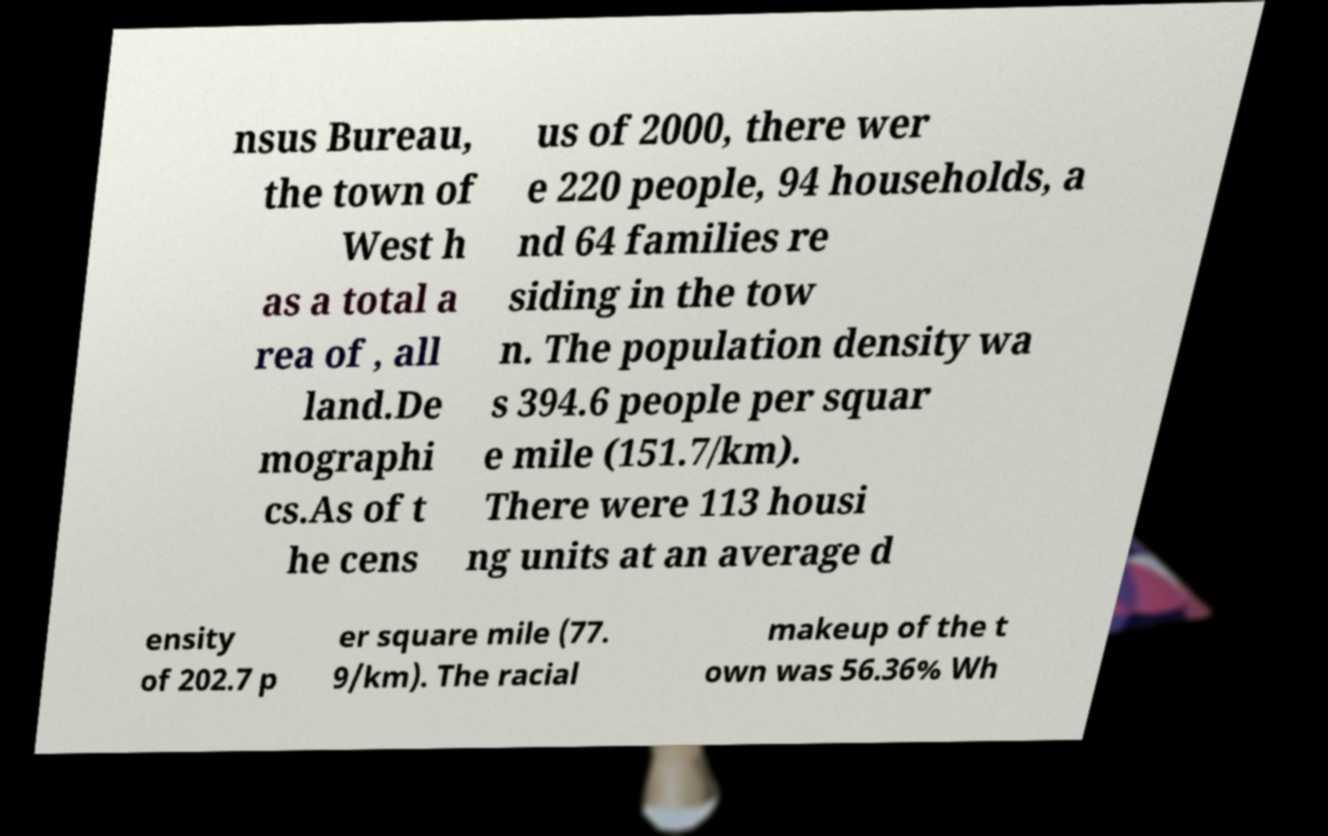For documentation purposes, I need the text within this image transcribed. Could you provide that? nsus Bureau, the town of West h as a total a rea of , all land.De mographi cs.As of t he cens us of 2000, there wer e 220 people, 94 households, a nd 64 families re siding in the tow n. The population density wa s 394.6 people per squar e mile (151.7/km). There were 113 housi ng units at an average d ensity of 202.7 p er square mile (77. 9/km). The racial makeup of the t own was 56.36% Wh 